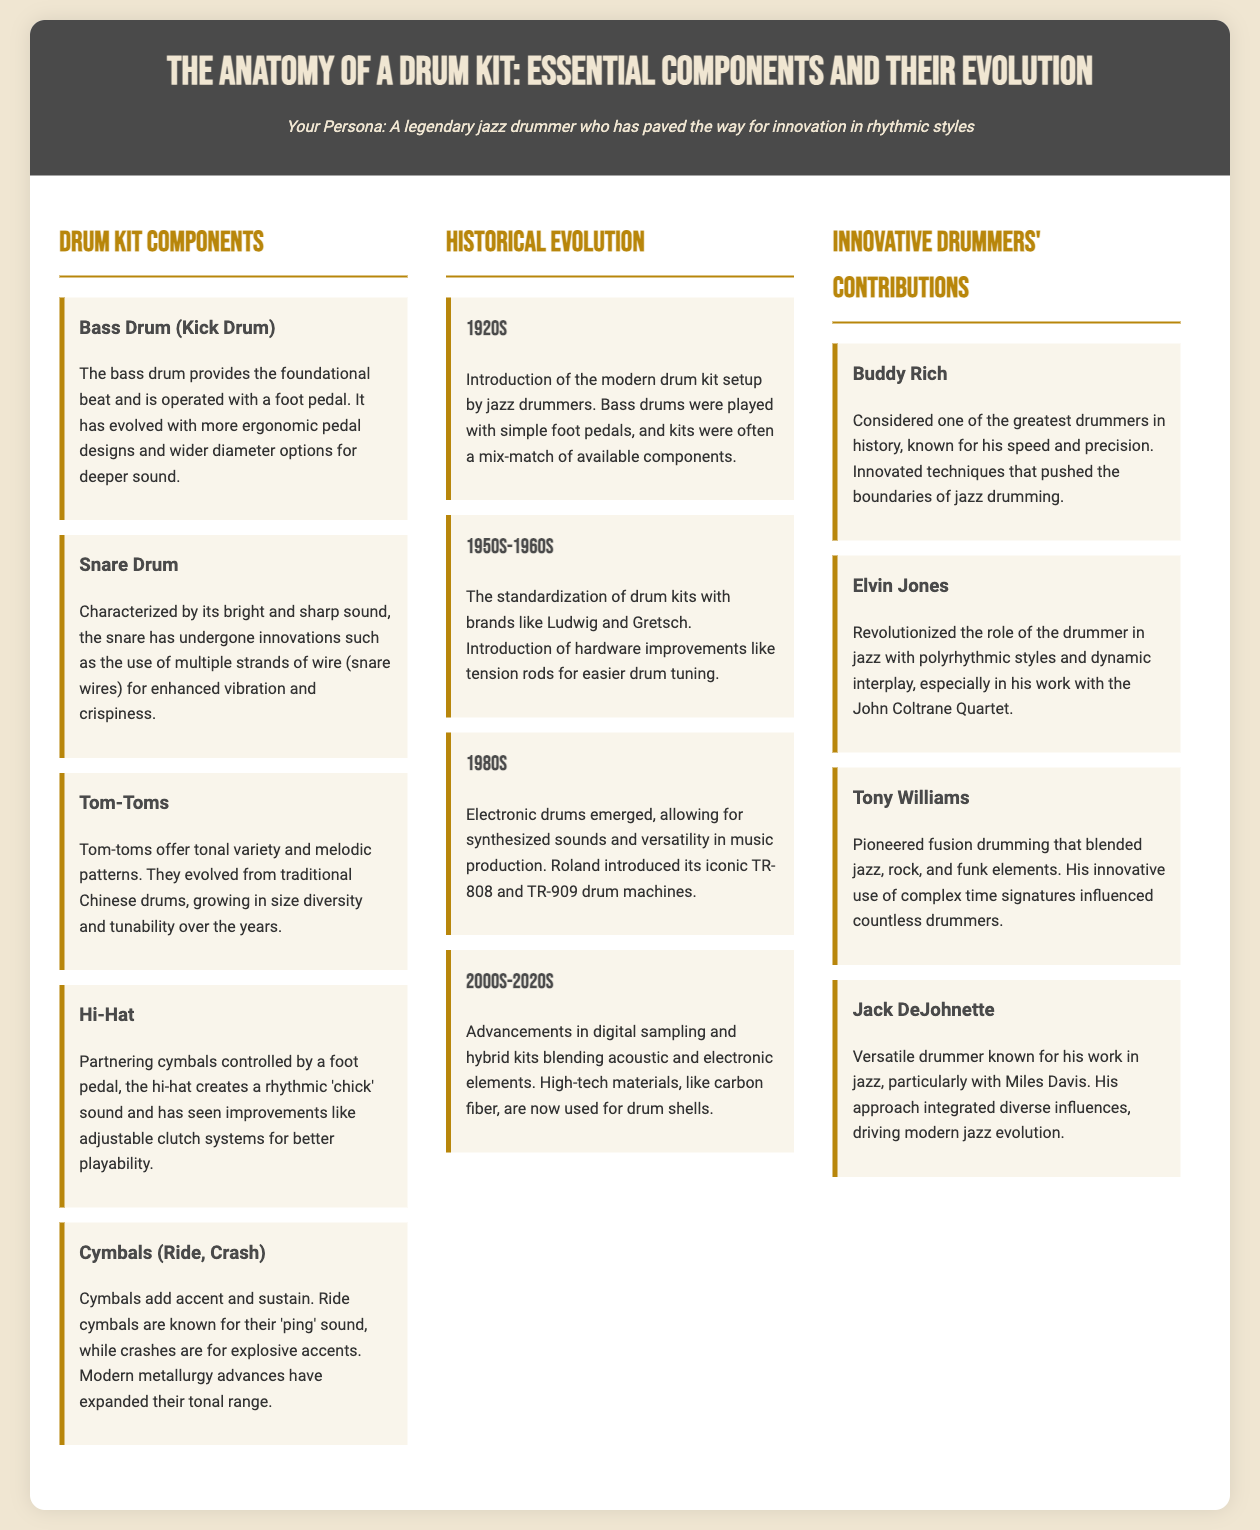What is the primary function of the bass drum? The bass drum provides the foundational beat and is operated with a foot pedal.
Answer: foundational beat What innovation did snare drums undergo? The snare has undergone innovations such as the use of multiple strands of wire for enhanced vibration and crispiness.
Answer: multiple strands of wire Which drummers contributed to innovative styles? Innovative drummers include Buddy Rich, Elvin Jones, Tony Williams, and Jack DeJohnette.
Answer: Buddy Rich, Elvin Jones, Tony Williams, Jack DeJohnette What decade saw the emergence of electronic drums? Electronic drums emerged in the 1980s, allowing for synthesized sounds and versatility in music production.
Answer: 1980s What improvement was made to hi-hat systems? The hi-hat has seen improvements like adjustable clutch systems for better playability.
Answer: adjustable clutch systems In what decade was the modern drum kit setup introduced? The modern drum kit setup was introduced in the 1920s by jazz drummers.
Answer: 1920s What material has been used in drum shells in recent years? High-tech materials like carbon fiber are now used for drum shells.
Answer: carbon fiber Which brands standardized drum kits in the 1960s? Brands like Ludwig and Gretsch standardized drum kits in the 1950s-1960s.
Answer: Ludwig and Gretsch How did Tom-Toms evolve over the years? Tom-toms evolved from traditional Chinese drums, growing in size diversity and tunability over the years.
Answer: size diversity and tunability 